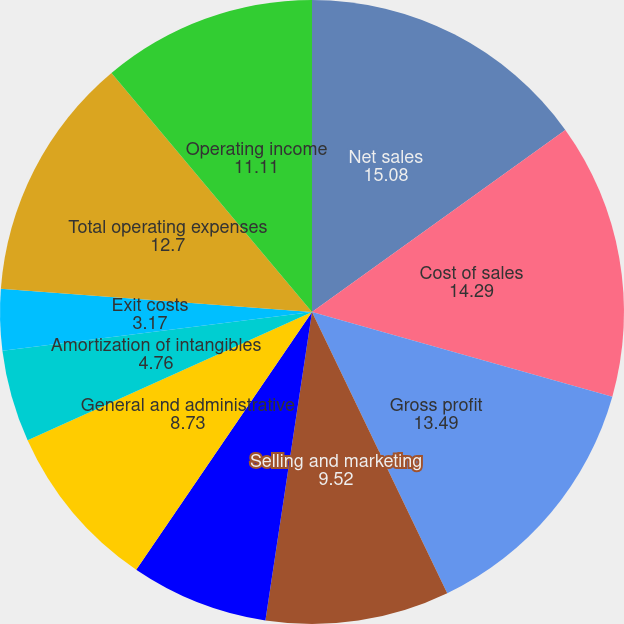Convert chart to OTSL. <chart><loc_0><loc_0><loc_500><loc_500><pie_chart><fcel>Net sales<fcel>Cost of sales<fcel>Gross profit<fcel>Selling and marketing<fcel>Research and engineering<fcel>General and administrative<fcel>Amortization of intangibles<fcel>Exit costs<fcel>Total operating expenses<fcel>Operating income<nl><fcel>15.08%<fcel>14.29%<fcel>13.49%<fcel>9.52%<fcel>7.14%<fcel>8.73%<fcel>4.76%<fcel>3.17%<fcel>12.7%<fcel>11.11%<nl></chart> 